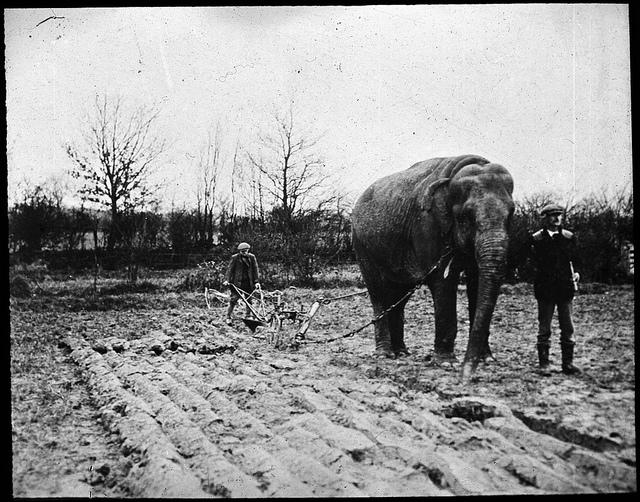Is there a baby elephant?
Be succinct. No. Is the elephant in the wild?
Be succinct. No. What type of animals are these?
Be succinct. Elephant. Who is pulling the elephant?
Short answer required. Man. Is the elephant plowing?
Answer briefly. Yes. In what year was this picture taken?
Give a very brief answer. 1940. What is the elephant pulling?
Give a very brief answer. Plow. 